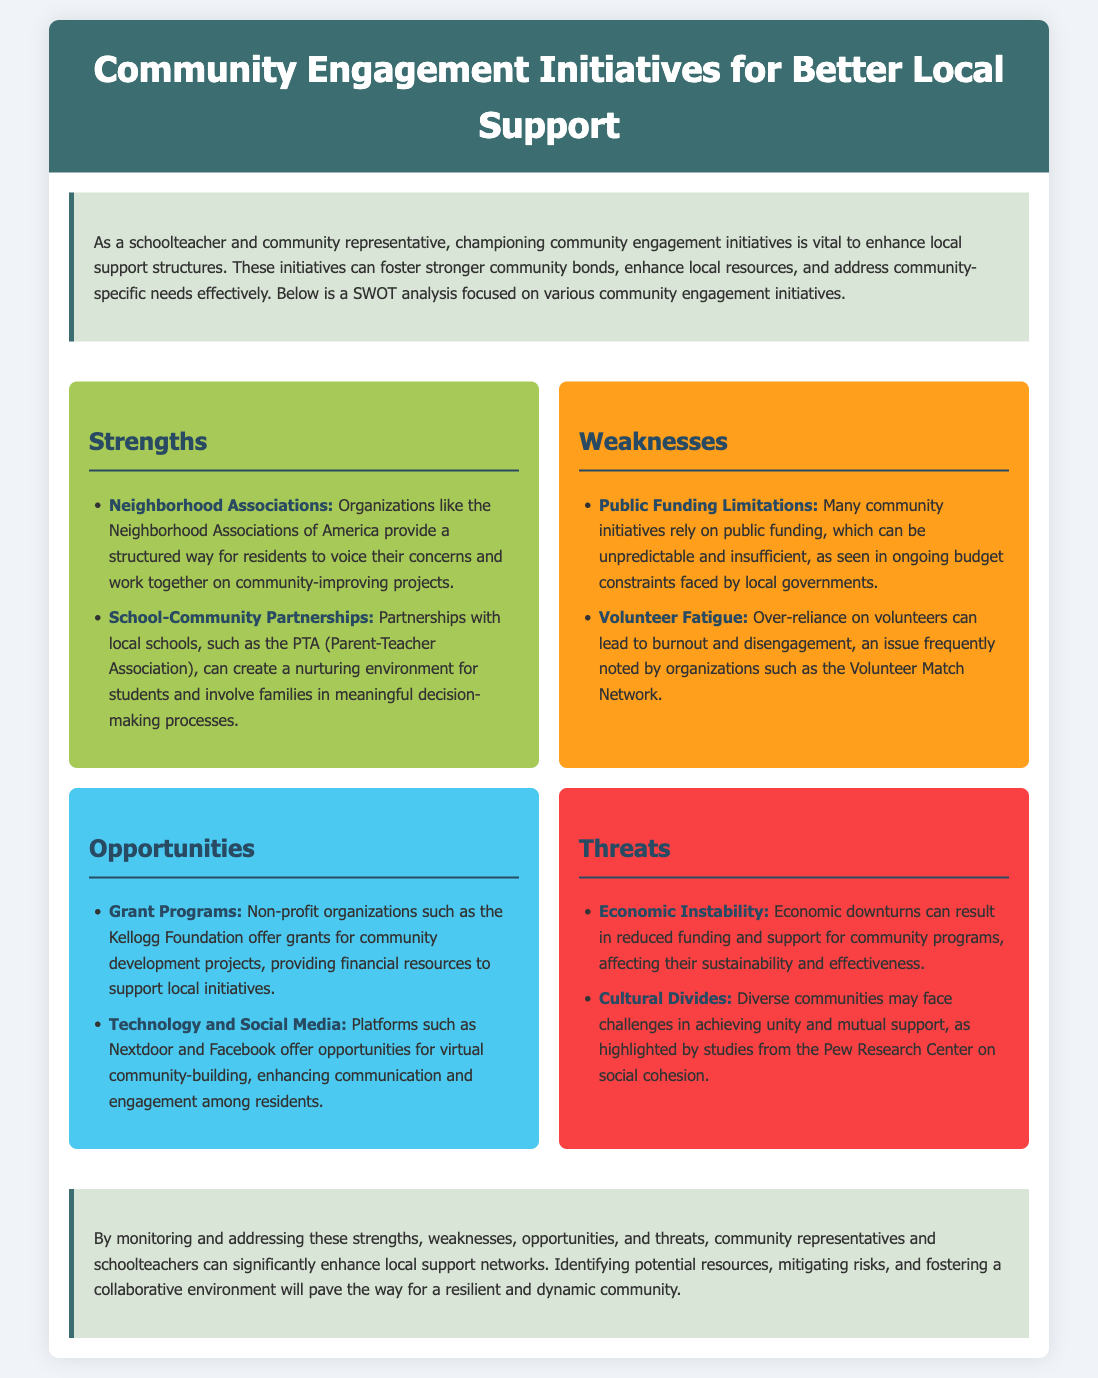What are the strengths listed in the SWOT analysis? The strengths are specific initiatives that help improve community engagement. They include Neighborhood Associations and School-Community Partnerships.
Answer: Neighborhood Associations, School-Community Partnerships How many weaknesses are identified in the document? The number of weaknesses is determined by counting the listed items in the weaknesses section, which includes two initiatives.
Answer: 2 What is one opportunity related to technology mentioned in the document? This refers to specific tools or platforms that enhance community engagement and are listed in the opportunities section. The document mentions Nextdoor and Facebook.
Answer: Nextdoor What economic factor is mentioned as a threat? This is a specific issue that can impact community support and funding, noted in the threats section of the analysis.
Answer: Economic Instability Which organization provides grants for community development projects? The document mentions specific non-profit organizations that offer financial support. This is explicitly named in the opportunities section.
Answer: Kellogg Foundation What is a key issue related to volunteer engagement mentioned in the weaknesses? This refers to a challenge faced by community initiatives when relying on volunteers. The document highlights the problem of burnout and disengagement.
Answer: Volunteer Fatigue What role do Neighborhood Associations play according to the strengths? This is about the function or impact of a specific initiative that encourages community involvement. The strengths section mentions their role as structured organizations for residents.
Answer: Voice their concerns What is one way to address cultural divides in communities? This relates to strategies or observations made in the analysis about fostering community unity. The document implies the need for mutual support through effective communication.
Answer: Achieving unity What color represents threats in the SWOT analysis? The document visually represents each section with specific colors, and the color for the threats section can be found in the formatting details.
Answer: Red 